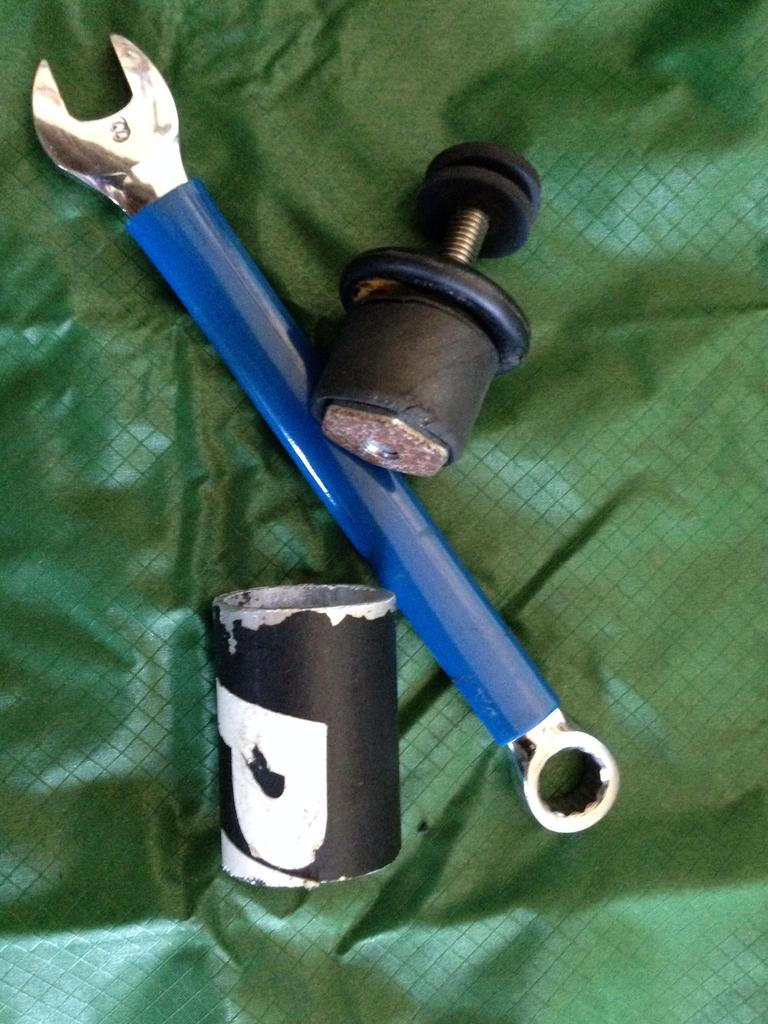What tool is visible in the image? There is a wrench in the image. What can be observed about the placement of objects in the image? There are objects placed on a surface in the image. What type of bed is visible in the image? There is no bed present in the image; it only features a wrench and objects placed on a surface. 